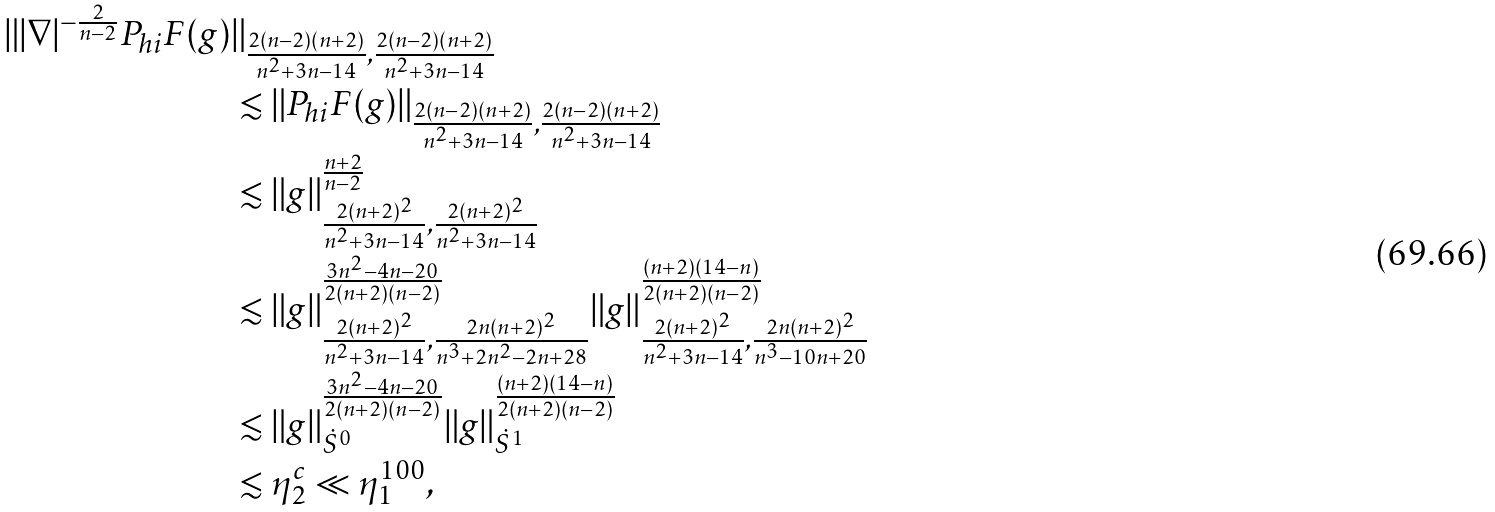Convert formula to latex. <formula><loc_0><loc_0><loc_500><loc_500>\| | \nabla | ^ { - \frac { 2 } { n - 2 } } P _ { h i } F ( g ) & \| _ { \frac { 2 ( n - 2 ) ( n + 2 ) } { n ^ { 2 } + 3 n - 1 4 } , \frac { 2 ( n - 2 ) ( n + 2 ) } { n ^ { 2 } + 3 n - 1 4 } } \\ & \lesssim \| P _ { h i } F ( g ) \| _ { \frac { 2 ( n - 2 ) ( n + 2 ) } { n ^ { 2 } + 3 n - 1 4 } , \frac { 2 ( n - 2 ) ( n + 2 ) } { n ^ { 2 } + 3 n - 1 4 } } \\ & \lesssim \| g \| _ { \frac { 2 ( n + 2 ) ^ { 2 } } { n ^ { 2 } + 3 n - 1 4 } , \frac { 2 ( n + 2 ) ^ { 2 } } { n ^ { 2 } + 3 n - 1 4 } } ^ { \frac { n + 2 } { n - 2 } } \\ & \lesssim \| g \| _ { \frac { 2 ( n + 2 ) ^ { 2 } } { n ^ { 2 } + 3 n - 1 4 } , \frac { 2 n ( n + 2 ) ^ { 2 } } { n ^ { 3 } + 2 n ^ { 2 } - 2 n + 2 8 } } ^ { \frac { 3 n ^ { 2 } - 4 n - 2 0 } { 2 ( n + 2 ) ( n - 2 ) } } \| g \| _ { \frac { 2 ( n + 2 ) ^ { 2 } } { n ^ { 2 } + 3 n - 1 4 } , \frac { 2 n ( n + 2 ) ^ { 2 } } { n ^ { 3 } - 1 0 n + 2 0 } } ^ { \frac { ( n + 2 ) ( 1 4 - n ) } { 2 ( n + 2 ) ( n - 2 ) } } \\ & \lesssim \| g \| _ { \dot { S } ^ { 0 } } ^ { \frac { 3 n ^ { 2 } - 4 n - 2 0 } { 2 ( n + 2 ) ( n - 2 ) } } \| g \| _ { \dot { S } ^ { 1 } } ^ { \frac { ( n + 2 ) ( 1 4 - n ) } { 2 ( n + 2 ) ( n - 2 ) } } \\ & \lesssim \eta _ { 2 } ^ { c } \ll \eta _ { 1 } ^ { 1 0 0 } ,</formula> 